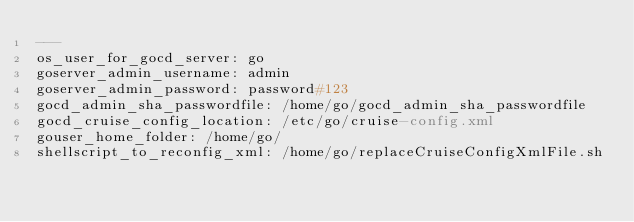Convert code to text. <code><loc_0><loc_0><loc_500><loc_500><_YAML_>---
os_user_for_gocd_server: go
goserver_admin_username: admin
goserver_admin_password: password#123
gocd_admin_sha_passwordfile: /home/go/gocd_admin_sha_passwordfile
gocd_cruise_config_location: /etc/go/cruise-config.xml
gouser_home_folder: /home/go/
shellscript_to_reconfig_xml: /home/go/replaceCruiseConfigXmlFile.sh</code> 